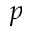<formula> <loc_0><loc_0><loc_500><loc_500>p</formula> 